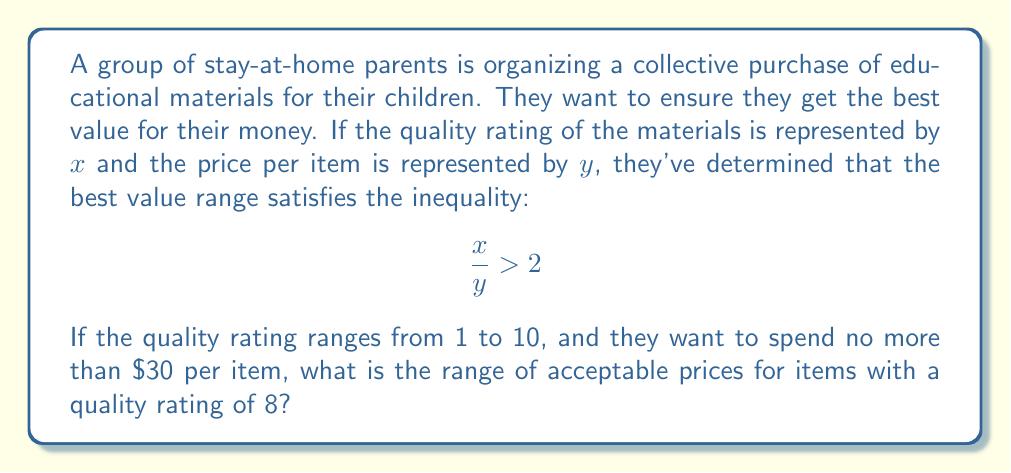Can you solve this math problem? Let's approach this step-by-step:

1) We start with the given inequality: $\frac{x}{y} > 2$

2) We're told that the quality rating for the items in question is 8, so we substitute $x = 8$:

   $\frac{8}{y} > 2$

3) To solve for $y$, we multiply both sides by $y$:

   $8 > 2y$

4) Then divide both sides by 2:

   $4 > y$

5) This means that for items with a quality rating of 8, the price should be less than $4 to meet the "best value" criterion.

6) However, we also need to consider the maximum price they're willing to pay, which is $30.

7) Therefore, the price range should be: $0 < y < 4$

8) In terms of dollars, this translates to: $0 < y \leq 4$ (since prices are typically not expressed as strict inequalities)

This range satisfies both the "best value" inequality and stays within the maximum price limit.
Answer: $0 < y \leq 4$ 